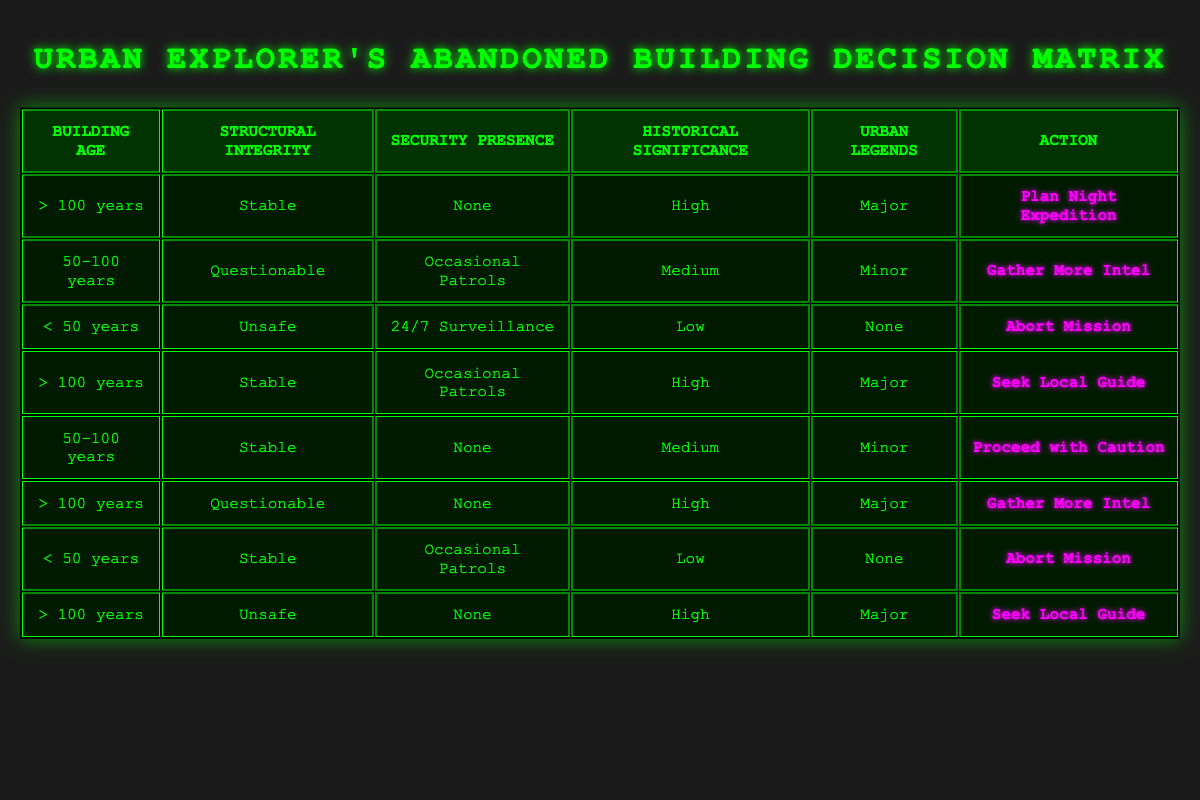What action should be taken for a building that is more than 100 years old, stable, has no security presence, and is historically significant with major urban legends? According to the table, under these conditions, the action prescribed is "Plan Night Expedition." This is found in the first row, which matches all specified conditions.
Answer: Plan Night Expedition What action is listed for buildings that are less than 50 years old and have unsafe structural integrity? The table indicates that for buildings under 50 years old with unsafe structural integrity, the action is "Abort Mission," as reflected in the third row.
Answer: Abort Mission How many different actions are associated with buildings older than 100 years? By checking the entries for buildings greater than 100 years, there are three actions identified: "Plan Night Expedition," "Seek Local Guide," and "Gather More Intel." This can be seen across multiple rows. Thus, the total is three distinct actions.
Answer: 3 Is there an action for buildings between 50 and 100 years old that have stable structural integrity and a medium level of historical significance? Yes, there is an action defined for this scenario: "Proceed with Caution," as noted in the fifth row of the table.
Answer: Yes What is the predominant action for buildings that have major urban legends associated with them and are at least 100 years old? To find the answer, I observe the rows for buildings over 100 years old. The actions associated are "Plan Night Expedition" and "Seek Local Guide," both of which apply when there are major urban legends. Therefore, these two actions are predominant for this scenario.
Answer: Plan Night Expedition, Seek Local Guide If a building is 50-100 years old, has questionable structural integrity, and experiences occasional patrols, what should the explorer do? The table specifies that these conditions lead to the action "Gather More Intel," which can be found in the second row.
Answer: Gather More Intel Is there any entry for buildings less than 50 years old with a high historical significance and unsafe structural integrity? No, there is no entry in the table that meets these criteria. All entries for buildings less than 50 years old with unsafe structural integrity are associated with "Abort Mission" and do not mention high historical significance.
Answer: No What is the least risky action according to the table for buildings aged between 50 and 100 years old without security presence? In the table, the least risky action is "Proceed with Caution," which applies to the building age of 50-100 years, stable condition, and no security presence. This is seen in the fifth row.
Answer: Proceed with Caution 